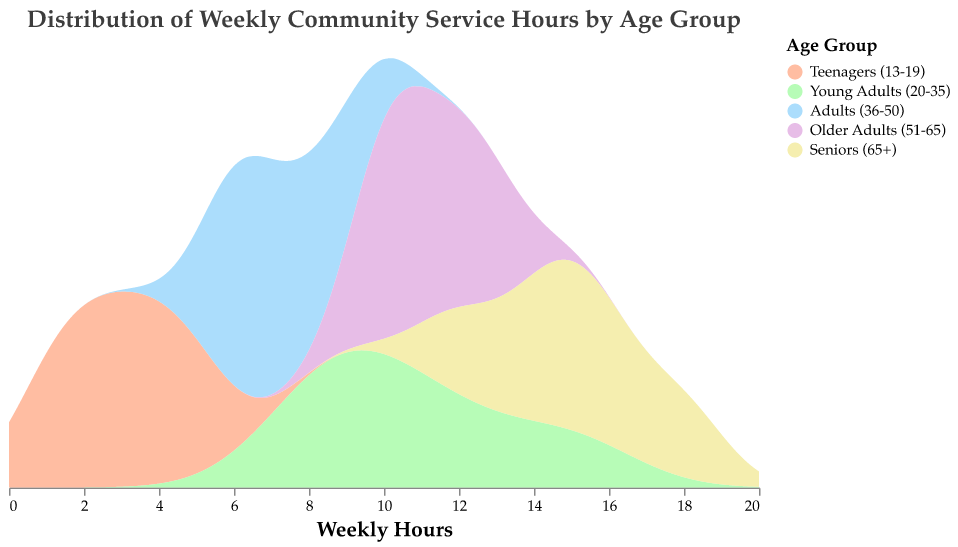What is the title of the plot? The title is usually at the top of the plot and provides a summary of what the plot represents.
Answer: Distribution of Weekly Community Service Hours by Age Group Which age group has the highest density of hours around the 10-hour mark? To identify this, you need to look at the peaks of the density distribution near the 10-hour mark and see which color has the highest peak.
Answer: Young Adults (20-35) Which age group demonstrates the most variation in weekly hours dedicated to community service based on the density curves? By examining the spread and peaks of the density curves, we can see that a wider spread with multiple peaks typically indicates more variation.
Answer: Seniors (65+) What is the average number of hours dedicated to community service by Teenagers (13-19)? Calculate the average by summing the hours (2+3+1+5+4) and dividing by the number of data points for that age group (5). (2+3+1+5+4)/5 = 15/5 = 3
Answer: 3 Which age group has the narrowest spread in their distribution of weekly hours? A narrow spread is where the density curve is closely packed around a certain value without spreading too widely.
Answer: Adults (36-50) Compare the density curves of Teenagers (13-19) and Young Adults (20-35) around the 5-hour mark. Which has a higher density? By looking at the density curves near the 5-hour mark, check which age group has a higher peak.
Answer: Teenagers (13-19) How do the distribution peaks for Older Adults (51-65) and Seniors (65+) compare around the 12-hour mark? You need to check both density curves around the 12-hour mark to see their respective peak densities.
Answer: Very close, with Seniors (65+) slightly higher Based on the plot, which age group appears most consistent in their community service hours? Consistency can be interpreted as less variation or tightly packed density peaks.
Answer: Adults (36-50) What is the total range of weekly hours observed across all age groups? The total range is determined by the minimum and maximum weekly hours reported in the data. Minimum is 1 hour, and maximum is 18 hours.
Answer: 1 to 18 hours 